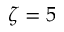Convert formula to latex. <formula><loc_0><loc_0><loc_500><loc_500>\zeta = 5</formula> 